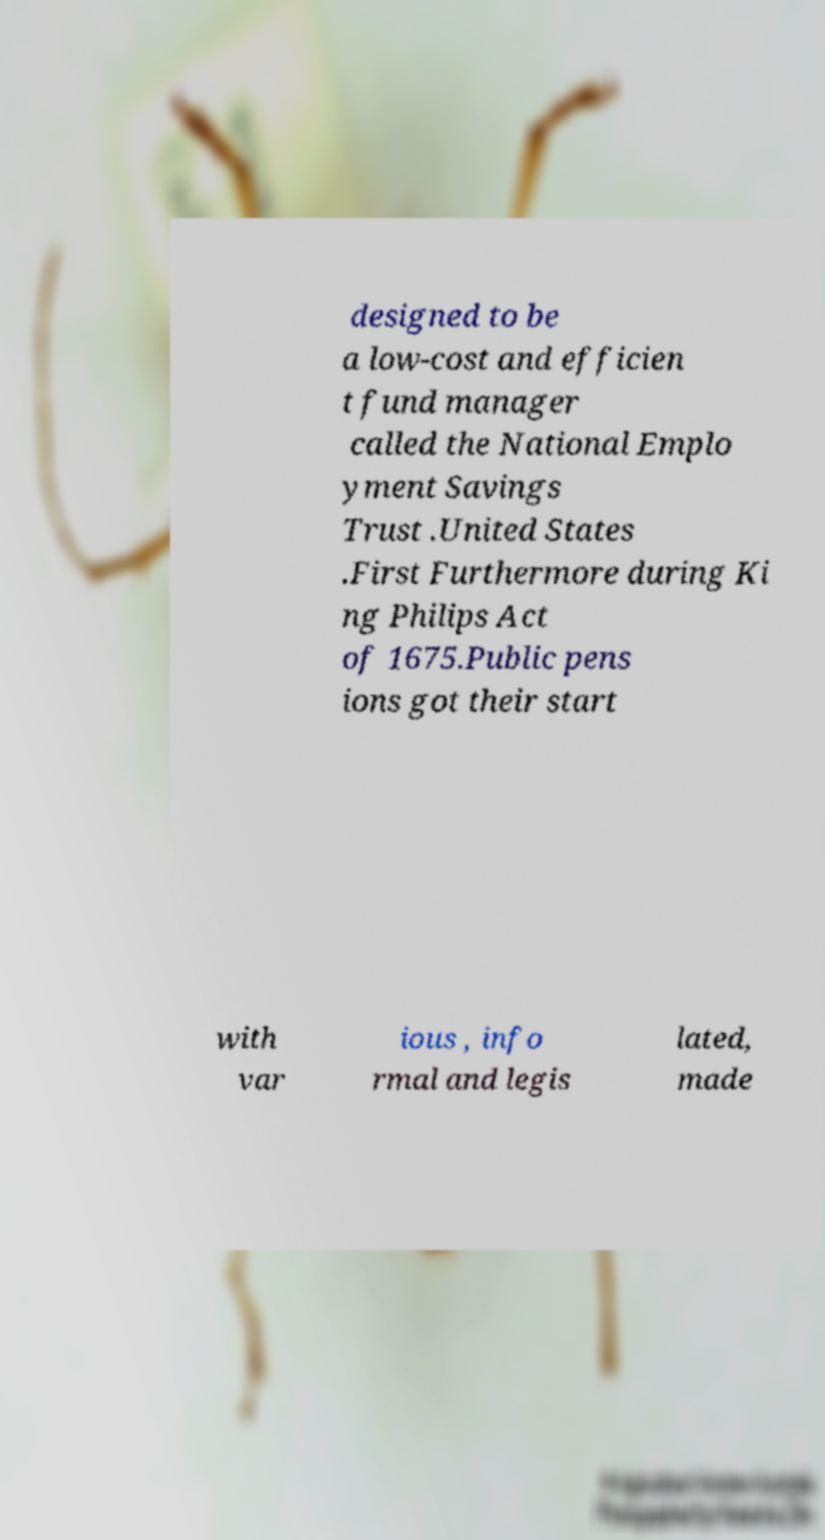What messages or text are displayed in this image? I need them in a readable, typed format. designed to be a low-cost and efficien t fund manager called the National Emplo yment Savings Trust .United States .First Furthermore during Ki ng Philips Act of 1675.Public pens ions got their start with var ious , info rmal and legis lated, made 